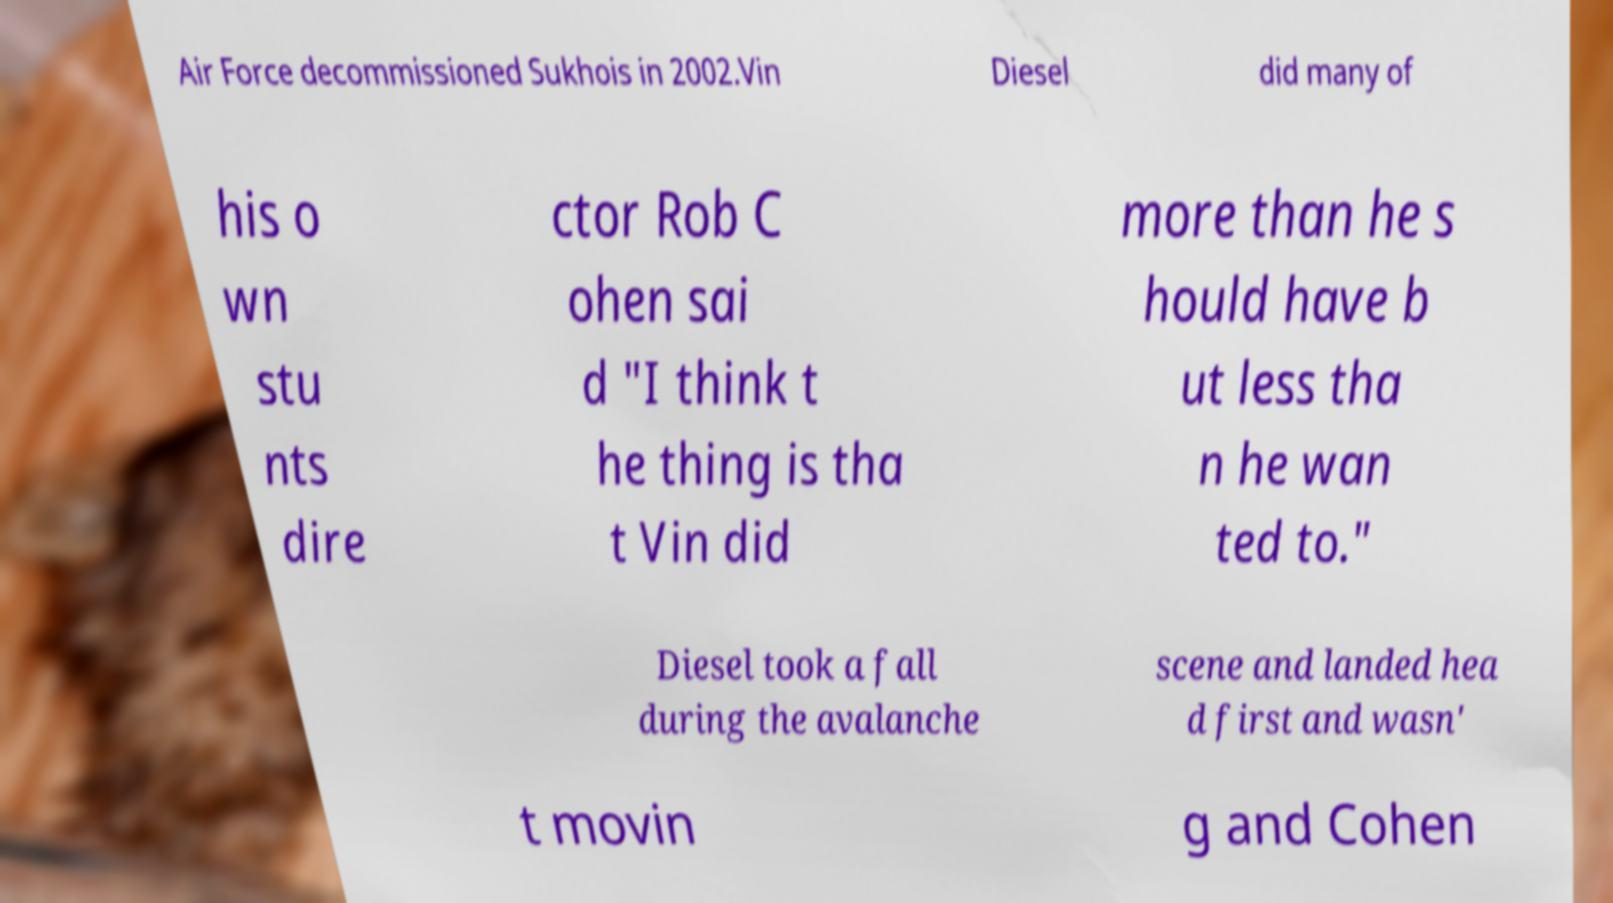Please identify and transcribe the text found in this image. Air Force decommissioned Sukhois in 2002.Vin Diesel did many of his o wn stu nts dire ctor Rob C ohen sai d "I think t he thing is tha t Vin did more than he s hould have b ut less tha n he wan ted to." Diesel took a fall during the avalanche scene and landed hea d first and wasn' t movin g and Cohen 